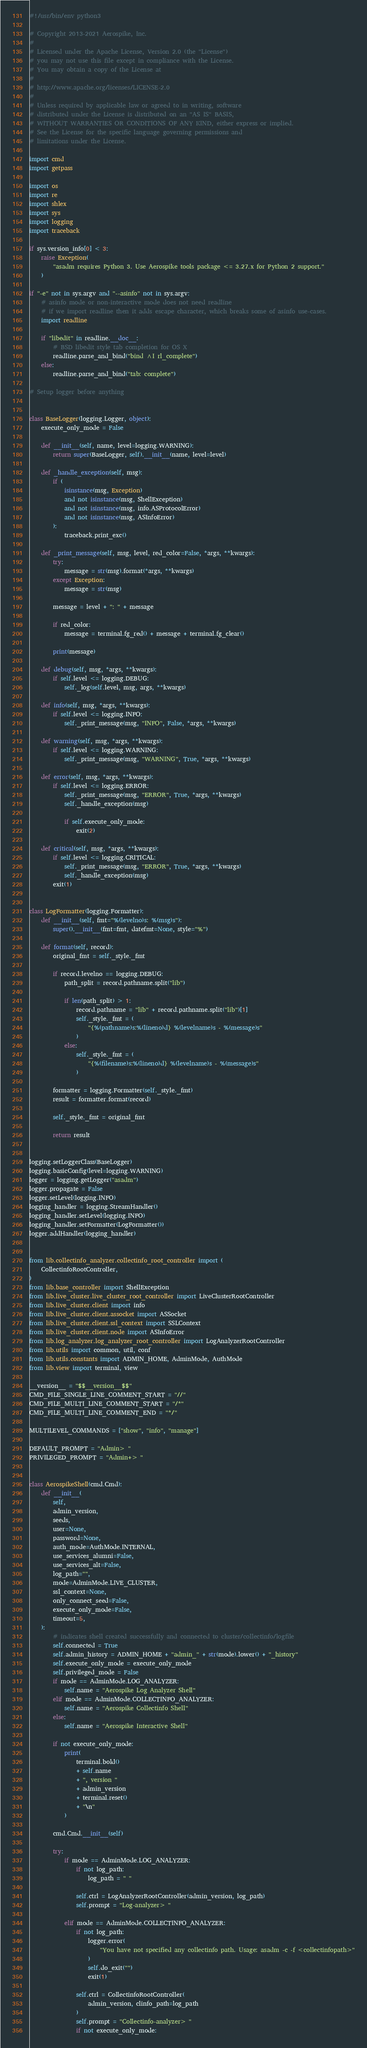Convert code to text. <code><loc_0><loc_0><loc_500><loc_500><_Python_>#!/usr/bin/env python3

# Copyright 2013-2021 Aerospike, Inc.
#
# Licensed under the Apache License, Version 2.0 (the "License")
# you may not use this file except in compliance with the License.
# You may obtain a copy of the License at
#
# http://www.apache.org/licenses/LICENSE-2.0
#
# Unless required by applicable law or agreed to in writing, software
# distributed under the License is distributed on an "AS IS" BASIS,
# WITHOUT WARRANTIES OR CONDITIONS OF ANY KIND, either express or implied.
# See the License for the specific language governing permissions and
# limitations under the License.

import cmd
import getpass

import os
import re
import shlex
import sys
import logging
import traceback

if sys.version_info[0] < 3:
    raise Exception(
        "asadm requires Python 3. Use Aerospike tools package <= 3.27.x for Python 2 support."
    )

if "-e" not in sys.argv and "--asinfo" not in sys.argv:
    # asinfo mode or non-interactive mode does not need readline
    # if we import readline then it adds escape character, which breaks some of asinfo use-cases.
    import readline

    if "libedit" in readline.__doc__:
        # BSD libedit style tab completion for OS X
        readline.parse_and_bind("bind ^I rl_complete")
    else:
        readline.parse_and_bind("tab: complete")

# Setup logger before anything


class BaseLogger(logging.Logger, object):
    execute_only_mode = False

    def __init__(self, name, level=logging.WARNING):
        return super(BaseLogger, self).__init__(name, level=level)

    def _handle_exception(self, msg):
        if (
            isinstance(msg, Exception)
            and not isinstance(msg, ShellException)
            and not isinstance(msg, info.ASProtocolError)
            and not isinstance(msg, ASInfoError)
        ):
            traceback.print_exc()

    def _print_message(self, msg, level, red_color=False, *args, **kwargs):
        try:
            message = str(msg).format(*args, **kwargs)
        except Exception:
            message = str(msg)

        message = level + ": " + message

        if red_color:
            message = terminal.fg_red() + message + terminal.fg_clear()

        print(message)

    def debug(self, msg, *args, **kwargs):
        if self.level <= logging.DEBUG:
            self._log(self.level, msg, args, **kwargs)

    def info(self, msg, *args, **kwargs):
        if self.level <= logging.INFO:
            self._print_message(msg, "INFO", False, *args, **kwargs)

    def warning(self, msg, *args, **kwargs):
        if self.level <= logging.WARNING:
            self._print_message(msg, "WARNING", True, *args, **kwargs)

    def error(self, msg, *args, **kwargs):
        if self.level <= logging.ERROR:
            self._print_message(msg, "ERROR", True, *args, **kwargs)
            self._handle_exception(msg)

            if self.execute_only_mode:
                exit(2)

    def critical(self, msg, *args, **kwargs):
        if self.level <= logging.CRITICAL:
            self._print_message(msg, "ERROR", True, *args, **kwargs)
            self._handle_exception(msg)
        exit(1)


class LogFormatter(logging.Formatter):
    def __init__(self, fmt="%(levelno)s: %(msg)s"):
        super().__init__(fmt=fmt, datefmt=None, style="%")

    def format(self, record):
        original_fmt = self._style._fmt

        if record.levelno == logging.DEBUG:
            path_split = record.pathname.split("lib")

            if len(path_split) > 1:
                record.pathname = "lib" + record.pathname.split("lib")[1]
                self._style._fmt = (
                    "{%(pathname)s:%(lineno)d} %(levelname)s - %(message)s"
                )
            else:
                self._style._fmt = (
                    "{%(filename)s:%(lineno)d} %(levelname)s - %(message)s"
                )

        formatter = logging.Formatter(self._style._fmt)
        result = formatter.format(record)

        self._style._fmt = original_fmt

        return result


logging.setLoggerClass(BaseLogger)
logging.basicConfig(level=logging.WARNING)
logger = logging.getLogger("asadm")
logger.propagate = False
logger.setLevel(logging.INFO)
logging_handler = logging.StreamHandler()
logging_handler.setLevel(logging.INFO)
logging_handler.setFormatter(LogFormatter())
logger.addHandler(logging_handler)


from lib.collectinfo_analyzer.collectinfo_root_controller import (
    CollectinfoRootController,
)
from lib.base_controller import ShellException
from lib.live_cluster.live_cluster_root_controller import LiveClusterRootController
from lib.live_cluster.client import info
from lib.live_cluster.client.assocket import ASSocket
from lib.live_cluster.client.ssl_context import SSLContext
from lib.live_cluster.client.node import ASInfoError
from lib.log_analyzer.log_analyzer_root_controller import LogAnalyzerRootController
from lib.utils import common, util, conf
from lib.utils.constants import ADMIN_HOME, AdminMode, AuthMode
from lib.view import terminal, view

__version__ = "$$__version__$$"
CMD_FILE_SINGLE_LINE_COMMENT_START = "//"
CMD_FILE_MULTI_LINE_COMMENT_START = "/*"
CMD_FILE_MULTI_LINE_COMMENT_END = "*/"

MULTILEVEL_COMMANDS = ["show", "info", "manage"]

DEFAULT_PROMPT = "Admin> "
PRIVILEGED_PROMPT = "Admin+> "


class AerospikeShell(cmd.Cmd):
    def __init__(
        self,
        admin_version,
        seeds,
        user=None,
        password=None,
        auth_mode=AuthMode.INTERNAL,
        use_services_alumni=False,
        use_services_alt=False,
        log_path="",
        mode=AdminMode.LIVE_CLUSTER,
        ssl_context=None,
        only_connect_seed=False,
        execute_only_mode=False,
        timeout=5,
    ):
        # indicates shell created successfully and connected to cluster/collectinfo/logfile
        self.connected = True
        self.admin_history = ADMIN_HOME + "admin_" + str(mode).lower() + "_history"
        self.execute_only_mode = execute_only_mode
        self.privileged_mode = False
        if mode == AdminMode.LOG_ANALYZER:
            self.name = "Aerospike Log Analyzer Shell"
        elif mode == AdminMode.COLLECTINFO_ANALYZER:
            self.name = "Aerospike Collectinfo Shell"
        else:
            self.name = "Aerospike Interactive Shell"

        if not execute_only_mode:
            print(
                terminal.bold()
                + self.name
                + ", version "
                + admin_version
                + terminal.reset()
                + "\n"
            )

        cmd.Cmd.__init__(self)

        try:
            if mode == AdminMode.LOG_ANALYZER:
                if not log_path:
                    log_path = " "

                self.ctrl = LogAnalyzerRootController(admin_version, log_path)
                self.prompt = "Log-analyzer> "

            elif mode == AdminMode.COLLECTINFO_ANALYZER:
                if not log_path:
                    logger.error(
                        "You have not specified any collectinfo path. Usage: asadm -c -f <collectinfopath>"
                    )
                    self.do_exit("")
                    exit(1)

                self.ctrl = CollectinfoRootController(
                    admin_version, clinfo_path=log_path
                )
                self.prompt = "Collectinfo-analyzer> "
                if not execute_only_mode:</code> 